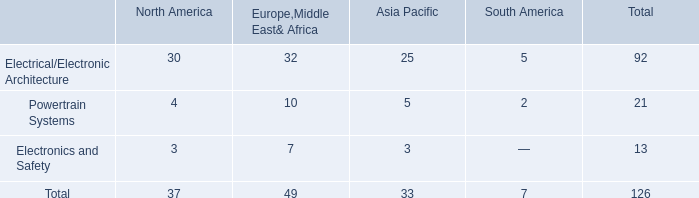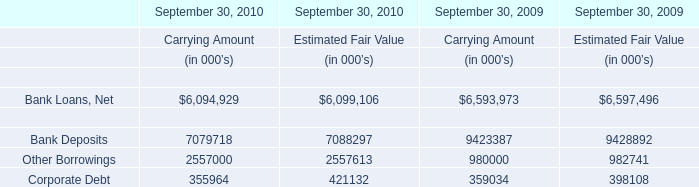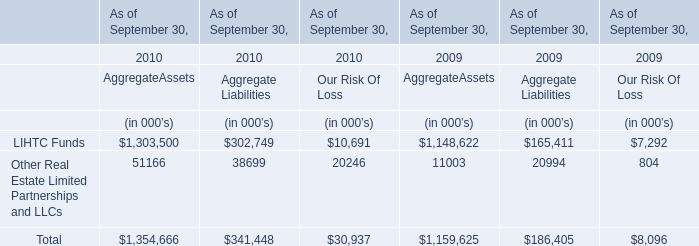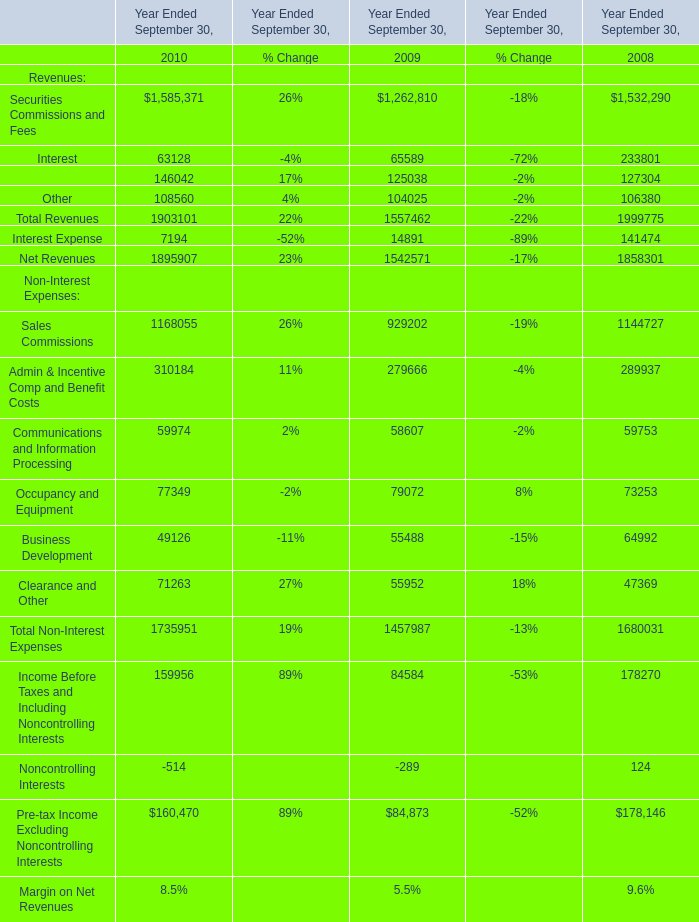What's the average of the Total for Financial Liabilities for AggregateAssets in the years where Bank Deposits for Financial Liabilities for Carrying Amount is positive? (in thousand) 
Computations: ((1354666 + 1159625) / 2)
Answer: 1257145.5. 